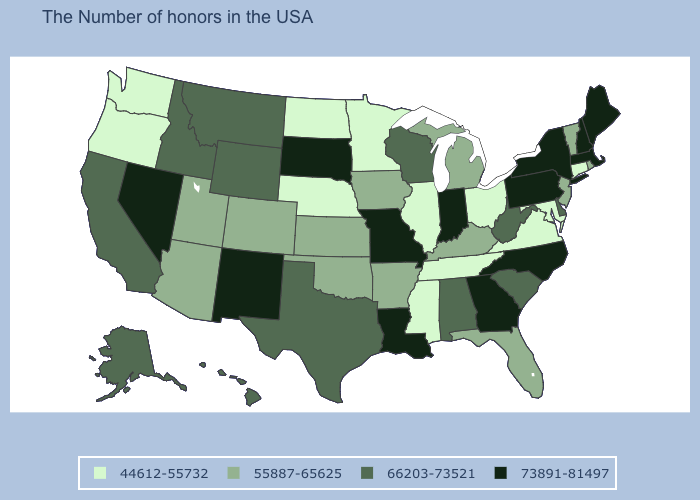Among the states that border Michigan , which have the lowest value?
Be succinct. Ohio. Name the states that have a value in the range 44612-55732?
Quick response, please. Connecticut, Maryland, Virginia, Ohio, Tennessee, Illinois, Mississippi, Minnesota, Nebraska, North Dakota, Washington, Oregon. Name the states that have a value in the range 44612-55732?
Keep it brief. Connecticut, Maryland, Virginia, Ohio, Tennessee, Illinois, Mississippi, Minnesota, Nebraska, North Dakota, Washington, Oregon. Does Oklahoma have a higher value than Alaska?
Concise answer only. No. Among the states that border Washington , does Oregon have the lowest value?
Quick response, please. Yes. What is the highest value in states that border Maine?
Concise answer only. 73891-81497. What is the lowest value in states that border Missouri?
Quick response, please. 44612-55732. Name the states that have a value in the range 55887-65625?
Give a very brief answer. Rhode Island, Vermont, New Jersey, Florida, Michigan, Kentucky, Arkansas, Iowa, Kansas, Oklahoma, Colorado, Utah, Arizona. Does the first symbol in the legend represent the smallest category?
Give a very brief answer. Yes. What is the highest value in states that border New Hampshire?
Give a very brief answer. 73891-81497. What is the lowest value in the USA?
Be succinct. 44612-55732. What is the lowest value in the USA?
Answer briefly. 44612-55732. What is the highest value in states that border Mississippi?
Give a very brief answer. 73891-81497. What is the value of Nebraska?
Short answer required. 44612-55732. 